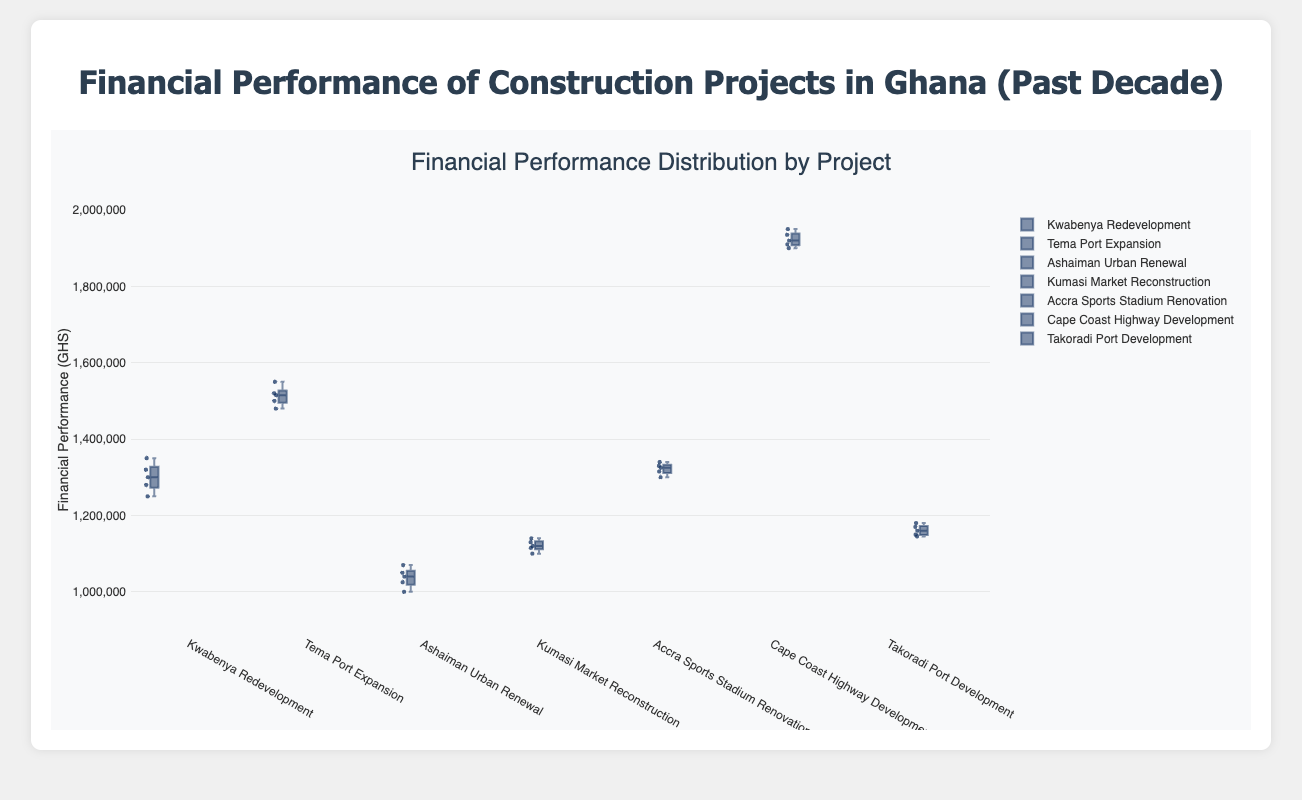What is the title of the figure? The title is typically located at the top of the figure and provides a summary of what the figure depicts. Here, it is "Financial Performance Distribution by Project".
Answer: Financial Performance Distribution by Project Which project has the highest median financial performance? To determine the highest median, look at the middle value of the box for each project. The Cape Coast Highway Development has the highest middle box value.
Answer: Cape Coast Highway Development What is the range of financial performance for the "Kumasi Market Reconstruction" project? The range in a box plot is found by subtracting the minimum value (lower whisker) from the maximum value (upper whisker). For Kumasi Market Reconstruction, this is 1140000 (maximum) - 1100000 (minimum).
Answer: 40000 Which project has the smallest interquartile range (IQR)? The IQR is the distance between the first quartile (bottom of the box) and the third quartile (top of the box). The "Kumasi Market Reconstruction" project has the smallest box, indicating the smallest IQR.
Answer: Kumasi Market Reconstruction How does the financial performance of the "Saglemi Housing Project" compare to the others? Since the Saglemi Housing Project is not included in the data, it cannot be compared directly with the others from this figure.
Answer: Not Applicable What is the median financial performance for the "Kwabenya Redevelopment" project? The median value is the line inside the box. For Kwabenya Redevelopment, this value seems to be around 1300000.
Answer: 1300000 Which project has the most outliers? Outliers are indicated by individual points outside the whiskers. Observing carefully, the "Cape Coast Highway Development" project has no distinct outliers displayed.
Answer: None Between "Takoradi Port Development" and "Tema Port Expansion," which has a higher maximum financial performance? The maximum financial performance is indicated by the top whisker. The "Tema Port Expansion" has the higher top whisker, indicating a higher maximum value.
Answer: Tema Port Expansion What is the difference in the median financial performances of the "Ashaiman Urban Renewal" and "Accra Sports Stadium Renovation" projects? Find the medians of each project and subtract them. Ashaiman Urban Renewal has a median around 1040000, and Accra Sports Stadium Renovation around 1325000. The difference is 1325000 - 1040000.
Answer: 285000 What overall trend can be observed from the financial performances of the listed projects? Observing the entire figure, you might notice that projects vary significantly in financial performance, with the Cape Coast Highway Development showing consistently higher financial performance.
Answer: Varies, with Cape Coast Highway Development highest 